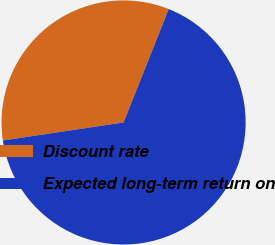Convert chart. <chart><loc_0><loc_0><loc_500><loc_500><pie_chart><fcel>Discount rate<fcel>Expected long-term return on<nl><fcel>33.39%<fcel>66.61%<nl></chart> 